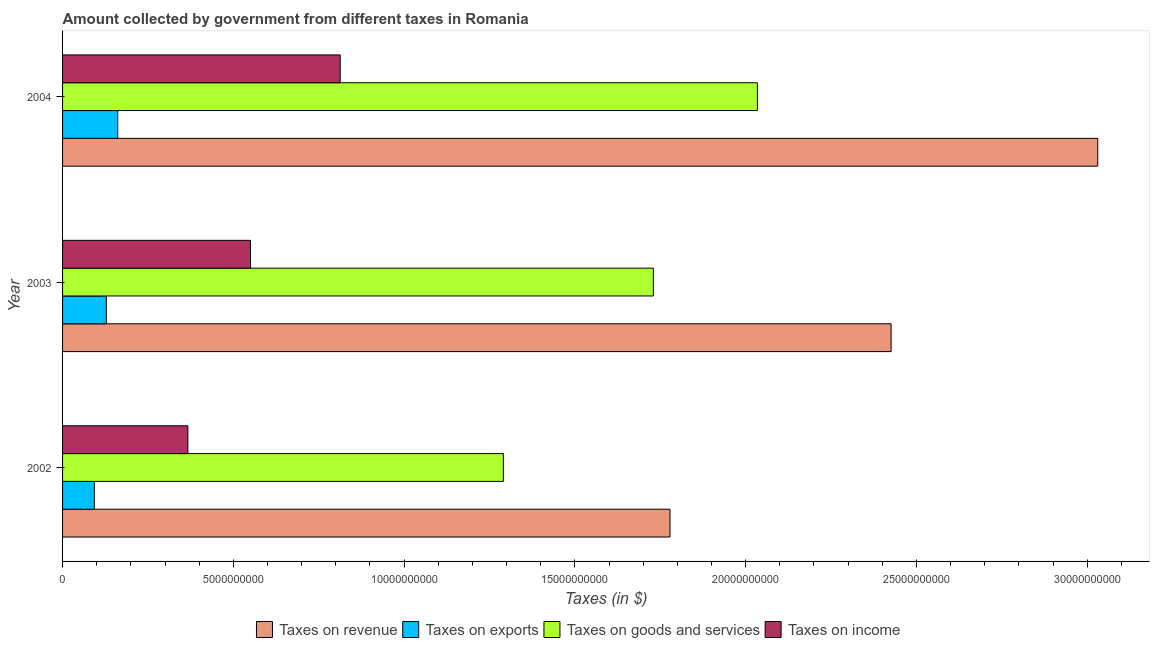How many different coloured bars are there?
Keep it short and to the point. 4. Are the number of bars per tick equal to the number of legend labels?
Give a very brief answer. Yes. What is the label of the 2nd group of bars from the top?
Ensure brevity in your answer.  2003. In how many cases, is the number of bars for a given year not equal to the number of legend labels?
Your answer should be compact. 0. What is the amount collected as tax on income in 2003?
Provide a short and direct response. 5.50e+09. Across all years, what is the maximum amount collected as tax on exports?
Give a very brief answer. 1.62e+09. Across all years, what is the minimum amount collected as tax on income?
Keep it short and to the point. 3.67e+09. In which year was the amount collected as tax on income maximum?
Offer a terse response. 2004. In which year was the amount collected as tax on exports minimum?
Provide a succinct answer. 2002. What is the total amount collected as tax on exports in the graph?
Ensure brevity in your answer.  3.83e+09. What is the difference between the amount collected as tax on goods in 2002 and that in 2004?
Your answer should be compact. -7.44e+09. What is the difference between the amount collected as tax on exports in 2004 and the amount collected as tax on income in 2002?
Provide a succinct answer. -2.05e+09. What is the average amount collected as tax on goods per year?
Offer a very short reply. 1.68e+1. In the year 2002, what is the difference between the amount collected as tax on income and amount collected as tax on revenue?
Give a very brief answer. -1.41e+1. What is the ratio of the amount collected as tax on goods in 2002 to that in 2003?
Offer a terse response. 0.75. Is the amount collected as tax on income in 2002 less than that in 2003?
Keep it short and to the point. Yes. What is the difference between the highest and the second highest amount collected as tax on exports?
Keep it short and to the point. 3.32e+08. What is the difference between the highest and the lowest amount collected as tax on income?
Your response must be concise. 4.46e+09. In how many years, is the amount collected as tax on exports greater than the average amount collected as tax on exports taken over all years?
Your answer should be compact. 2. Is it the case that in every year, the sum of the amount collected as tax on income and amount collected as tax on revenue is greater than the sum of amount collected as tax on exports and amount collected as tax on goods?
Provide a short and direct response. No. What does the 4th bar from the top in 2004 represents?
Your answer should be very brief. Taxes on revenue. What does the 1st bar from the bottom in 2003 represents?
Ensure brevity in your answer.  Taxes on revenue. Is it the case that in every year, the sum of the amount collected as tax on revenue and amount collected as tax on exports is greater than the amount collected as tax on goods?
Offer a terse response. Yes. How many bars are there?
Your response must be concise. 12. Are all the bars in the graph horizontal?
Your answer should be very brief. Yes. How many years are there in the graph?
Ensure brevity in your answer.  3. Are the values on the major ticks of X-axis written in scientific E-notation?
Provide a succinct answer. No. Where does the legend appear in the graph?
Keep it short and to the point. Bottom center. How many legend labels are there?
Provide a succinct answer. 4. What is the title of the graph?
Offer a terse response. Amount collected by government from different taxes in Romania. Does "Denmark" appear as one of the legend labels in the graph?
Keep it short and to the point. No. What is the label or title of the X-axis?
Keep it short and to the point. Taxes (in $). What is the label or title of the Y-axis?
Offer a terse response. Year. What is the Taxes (in $) in Taxes on revenue in 2002?
Your answer should be very brief. 1.78e+1. What is the Taxes (in $) of Taxes on exports in 2002?
Your answer should be very brief. 9.30e+08. What is the Taxes (in $) of Taxes on goods and services in 2002?
Keep it short and to the point. 1.29e+1. What is the Taxes (in $) of Taxes on income in 2002?
Your answer should be compact. 3.67e+09. What is the Taxes (in $) of Taxes on revenue in 2003?
Your response must be concise. 2.43e+1. What is the Taxes (in $) of Taxes on exports in 2003?
Make the answer very short. 1.28e+09. What is the Taxes (in $) in Taxes on goods and services in 2003?
Provide a short and direct response. 1.73e+1. What is the Taxes (in $) in Taxes on income in 2003?
Your response must be concise. 5.50e+09. What is the Taxes (in $) of Taxes on revenue in 2004?
Provide a succinct answer. 3.03e+1. What is the Taxes (in $) of Taxes on exports in 2004?
Your answer should be very brief. 1.62e+09. What is the Taxes (in $) in Taxes on goods and services in 2004?
Your response must be concise. 2.03e+1. What is the Taxes (in $) in Taxes on income in 2004?
Keep it short and to the point. 8.13e+09. Across all years, what is the maximum Taxes (in $) of Taxes on revenue?
Offer a terse response. 3.03e+1. Across all years, what is the maximum Taxes (in $) in Taxes on exports?
Your response must be concise. 1.62e+09. Across all years, what is the maximum Taxes (in $) of Taxes on goods and services?
Your response must be concise. 2.03e+1. Across all years, what is the maximum Taxes (in $) of Taxes on income?
Provide a succinct answer. 8.13e+09. Across all years, what is the minimum Taxes (in $) of Taxes on revenue?
Your answer should be compact. 1.78e+1. Across all years, what is the minimum Taxes (in $) in Taxes on exports?
Ensure brevity in your answer.  9.30e+08. Across all years, what is the minimum Taxes (in $) in Taxes on goods and services?
Offer a very short reply. 1.29e+1. Across all years, what is the minimum Taxes (in $) of Taxes on income?
Provide a short and direct response. 3.67e+09. What is the total Taxes (in $) in Taxes on revenue in the graph?
Ensure brevity in your answer.  7.24e+1. What is the total Taxes (in $) of Taxes on exports in the graph?
Make the answer very short. 3.83e+09. What is the total Taxes (in $) of Taxes on goods and services in the graph?
Give a very brief answer. 5.05e+1. What is the total Taxes (in $) of Taxes on income in the graph?
Your response must be concise. 1.73e+1. What is the difference between the Taxes (in $) of Taxes on revenue in 2002 and that in 2003?
Provide a succinct answer. -6.47e+09. What is the difference between the Taxes (in $) of Taxes on exports in 2002 and that in 2003?
Make the answer very short. -3.53e+08. What is the difference between the Taxes (in $) in Taxes on goods and services in 2002 and that in 2003?
Your answer should be very brief. -4.39e+09. What is the difference between the Taxes (in $) in Taxes on income in 2002 and that in 2003?
Provide a succinct answer. -1.83e+09. What is the difference between the Taxes (in $) in Taxes on revenue in 2002 and that in 2004?
Your response must be concise. -1.25e+1. What is the difference between the Taxes (in $) in Taxes on exports in 2002 and that in 2004?
Make the answer very short. -6.85e+08. What is the difference between the Taxes (in $) of Taxes on goods and services in 2002 and that in 2004?
Keep it short and to the point. -7.44e+09. What is the difference between the Taxes (in $) of Taxes on income in 2002 and that in 2004?
Offer a very short reply. -4.46e+09. What is the difference between the Taxes (in $) of Taxes on revenue in 2003 and that in 2004?
Ensure brevity in your answer.  -6.05e+09. What is the difference between the Taxes (in $) of Taxes on exports in 2003 and that in 2004?
Keep it short and to the point. -3.32e+08. What is the difference between the Taxes (in $) in Taxes on goods and services in 2003 and that in 2004?
Provide a short and direct response. -3.05e+09. What is the difference between the Taxes (in $) of Taxes on income in 2003 and that in 2004?
Provide a succinct answer. -2.63e+09. What is the difference between the Taxes (in $) of Taxes on revenue in 2002 and the Taxes (in $) of Taxes on exports in 2003?
Your answer should be very brief. 1.65e+1. What is the difference between the Taxes (in $) of Taxes on revenue in 2002 and the Taxes (in $) of Taxes on goods and services in 2003?
Your response must be concise. 4.86e+08. What is the difference between the Taxes (in $) of Taxes on revenue in 2002 and the Taxes (in $) of Taxes on income in 2003?
Provide a succinct answer. 1.23e+1. What is the difference between the Taxes (in $) of Taxes on exports in 2002 and the Taxes (in $) of Taxes on goods and services in 2003?
Keep it short and to the point. -1.64e+1. What is the difference between the Taxes (in $) of Taxes on exports in 2002 and the Taxes (in $) of Taxes on income in 2003?
Your answer should be very brief. -4.57e+09. What is the difference between the Taxes (in $) of Taxes on goods and services in 2002 and the Taxes (in $) of Taxes on income in 2003?
Ensure brevity in your answer.  7.40e+09. What is the difference between the Taxes (in $) of Taxes on revenue in 2002 and the Taxes (in $) of Taxes on exports in 2004?
Your response must be concise. 1.62e+1. What is the difference between the Taxes (in $) of Taxes on revenue in 2002 and the Taxes (in $) of Taxes on goods and services in 2004?
Offer a terse response. -2.56e+09. What is the difference between the Taxes (in $) in Taxes on revenue in 2002 and the Taxes (in $) in Taxes on income in 2004?
Ensure brevity in your answer.  9.66e+09. What is the difference between the Taxes (in $) in Taxes on exports in 2002 and the Taxes (in $) in Taxes on goods and services in 2004?
Your response must be concise. -1.94e+1. What is the difference between the Taxes (in $) of Taxes on exports in 2002 and the Taxes (in $) of Taxes on income in 2004?
Offer a terse response. -7.20e+09. What is the difference between the Taxes (in $) in Taxes on goods and services in 2002 and the Taxes (in $) in Taxes on income in 2004?
Give a very brief answer. 4.78e+09. What is the difference between the Taxes (in $) of Taxes on revenue in 2003 and the Taxes (in $) of Taxes on exports in 2004?
Give a very brief answer. 2.26e+1. What is the difference between the Taxes (in $) in Taxes on revenue in 2003 and the Taxes (in $) in Taxes on goods and services in 2004?
Keep it short and to the point. 3.91e+09. What is the difference between the Taxes (in $) in Taxes on revenue in 2003 and the Taxes (in $) in Taxes on income in 2004?
Offer a very short reply. 1.61e+1. What is the difference between the Taxes (in $) of Taxes on exports in 2003 and the Taxes (in $) of Taxes on goods and services in 2004?
Provide a succinct answer. -1.91e+1. What is the difference between the Taxes (in $) of Taxes on exports in 2003 and the Taxes (in $) of Taxes on income in 2004?
Give a very brief answer. -6.85e+09. What is the difference between the Taxes (in $) in Taxes on goods and services in 2003 and the Taxes (in $) in Taxes on income in 2004?
Give a very brief answer. 9.17e+09. What is the average Taxes (in $) of Taxes on revenue per year?
Provide a succinct answer. 2.41e+1. What is the average Taxes (in $) in Taxes on exports per year?
Ensure brevity in your answer.  1.28e+09. What is the average Taxes (in $) of Taxes on goods and services per year?
Your response must be concise. 1.68e+1. What is the average Taxes (in $) of Taxes on income per year?
Offer a very short reply. 5.77e+09. In the year 2002, what is the difference between the Taxes (in $) of Taxes on revenue and Taxes (in $) of Taxes on exports?
Offer a terse response. 1.69e+1. In the year 2002, what is the difference between the Taxes (in $) in Taxes on revenue and Taxes (in $) in Taxes on goods and services?
Provide a short and direct response. 4.88e+09. In the year 2002, what is the difference between the Taxes (in $) in Taxes on revenue and Taxes (in $) in Taxes on income?
Keep it short and to the point. 1.41e+1. In the year 2002, what is the difference between the Taxes (in $) of Taxes on exports and Taxes (in $) of Taxes on goods and services?
Keep it short and to the point. -1.20e+1. In the year 2002, what is the difference between the Taxes (in $) of Taxes on exports and Taxes (in $) of Taxes on income?
Your response must be concise. -2.74e+09. In the year 2002, what is the difference between the Taxes (in $) of Taxes on goods and services and Taxes (in $) of Taxes on income?
Offer a very short reply. 9.24e+09. In the year 2003, what is the difference between the Taxes (in $) in Taxes on revenue and Taxes (in $) in Taxes on exports?
Provide a short and direct response. 2.30e+1. In the year 2003, what is the difference between the Taxes (in $) of Taxes on revenue and Taxes (in $) of Taxes on goods and services?
Your response must be concise. 6.96e+09. In the year 2003, what is the difference between the Taxes (in $) in Taxes on revenue and Taxes (in $) in Taxes on income?
Make the answer very short. 1.88e+1. In the year 2003, what is the difference between the Taxes (in $) in Taxes on exports and Taxes (in $) in Taxes on goods and services?
Your response must be concise. -1.60e+1. In the year 2003, what is the difference between the Taxes (in $) in Taxes on exports and Taxes (in $) in Taxes on income?
Your response must be concise. -4.22e+09. In the year 2003, what is the difference between the Taxes (in $) of Taxes on goods and services and Taxes (in $) of Taxes on income?
Keep it short and to the point. 1.18e+1. In the year 2004, what is the difference between the Taxes (in $) of Taxes on revenue and Taxes (in $) of Taxes on exports?
Offer a terse response. 2.87e+1. In the year 2004, what is the difference between the Taxes (in $) of Taxes on revenue and Taxes (in $) of Taxes on goods and services?
Keep it short and to the point. 9.96e+09. In the year 2004, what is the difference between the Taxes (in $) in Taxes on revenue and Taxes (in $) in Taxes on income?
Provide a succinct answer. 2.22e+1. In the year 2004, what is the difference between the Taxes (in $) of Taxes on exports and Taxes (in $) of Taxes on goods and services?
Your answer should be very brief. -1.87e+1. In the year 2004, what is the difference between the Taxes (in $) in Taxes on exports and Taxes (in $) in Taxes on income?
Offer a very short reply. -6.51e+09. In the year 2004, what is the difference between the Taxes (in $) in Taxes on goods and services and Taxes (in $) in Taxes on income?
Your answer should be compact. 1.22e+1. What is the ratio of the Taxes (in $) in Taxes on revenue in 2002 to that in 2003?
Offer a terse response. 0.73. What is the ratio of the Taxes (in $) of Taxes on exports in 2002 to that in 2003?
Offer a very short reply. 0.72. What is the ratio of the Taxes (in $) in Taxes on goods and services in 2002 to that in 2003?
Ensure brevity in your answer.  0.75. What is the ratio of the Taxes (in $) of Taxes on revenue in 2002 to that in 2004?
Give a very brief answer. 0.59. What is the ratio of the Taxes (in $) of Taxes on exports in 2002 to that in 2004?
Provide a succinct answer. 0.58. What is the ratio of the Taxes (in $) in Taxes on goods and services in 2002 to that in 2004?
Ensure brevity in your answer.  0.63. What is the ratio of the Taxes (in $) in Taxes on income in 2002 to that in 2004?
Give a very brief answer. 0.45. What is the ratio of the Taxes (in $) of Taxes on revenue in 2003 to that in 2004?
Provide a short and direct response. 0.8. What is the ratio of the Taxes (in $) of Taxes on exports in 2003 to that in 2004?
Your answer should be very brief. 0.79. What is the ratio of the Taxes (in $) in Taxes on goods and services in 2003 to that in 2004?
Give a very brief answer. 0.85. What is the ratio of the Taxes (in $) of Taxes on income in 2003 to that in 2004?
Keep it short and to the point. 0.68. What is the difference between the highest and the second highest Taxes (in $) of Taxes on revenue?
Your answer should be very brief. 6.05e+09. What is the difference between the highest and the second highest Taxes (in $) in Taxes on exports?
Offer a very short reply. 3.32e+08. What is the difference between the highest and the second highest Taxes (in $) of Taxes on goods and services?
Keep it short and to the point. 3.05e+09. What is the difference between the highest and the second highest Taxes (in $) of Taxes on income?
Your answer should be compact. 2.63e+09. What is the difference between the highest and the lowest Taxes (in $) of Taxes on revenue?
Provide a short and direct response. 1.25e+1. What is the difference between the highest and the lowest Taxes (in $) in Taxes on exports?
Ensure brevity in your answer.  6.85e+08. What is the difference between the highest and the lowest Taxes (in $) of Taxes on goods and services?
Make the answer very short. 7.44e+09. What is the difference between the highest and the lowest Taxes (in $) in Taxes on income?
Give a very brief answer. 4.46e+09. 